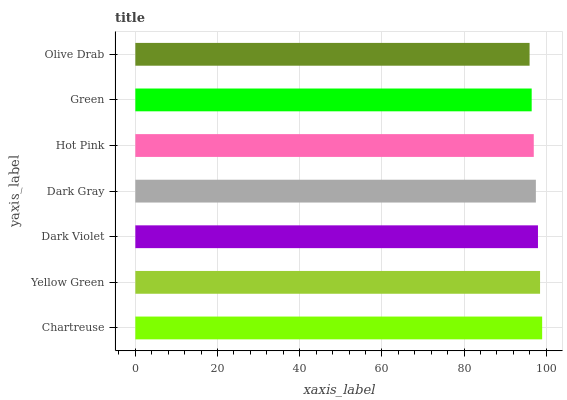Is Olive Drab the minimum?
Answer yes or no. Yes. Is Chartreuse the maximum?
Answer yes or no. Yes. Is Yellow Green the minimum?
Answer yes or no. No. Is Yellow Green the maximum?
Answer yes or no. No. Is Chartreuse greater than Yellow Green?
Answer yes or no. Yes. Is Yellow Green less than Chartreuse?
Answer yes or no. Yes. Is Yellow Green greater than Chartreuse?
Answer yes or no. No. Is Chartreuse less than Yellow Green?
Answer yes or no. No. Is Dark Gray the high median?
Answer yes or no. Yes. Is Dark Gray the low median?
Answer yes or no. Yes. Is Green the high median?
Answer yes or no. No. Is Green the low median?
Answer yes or no. No. 